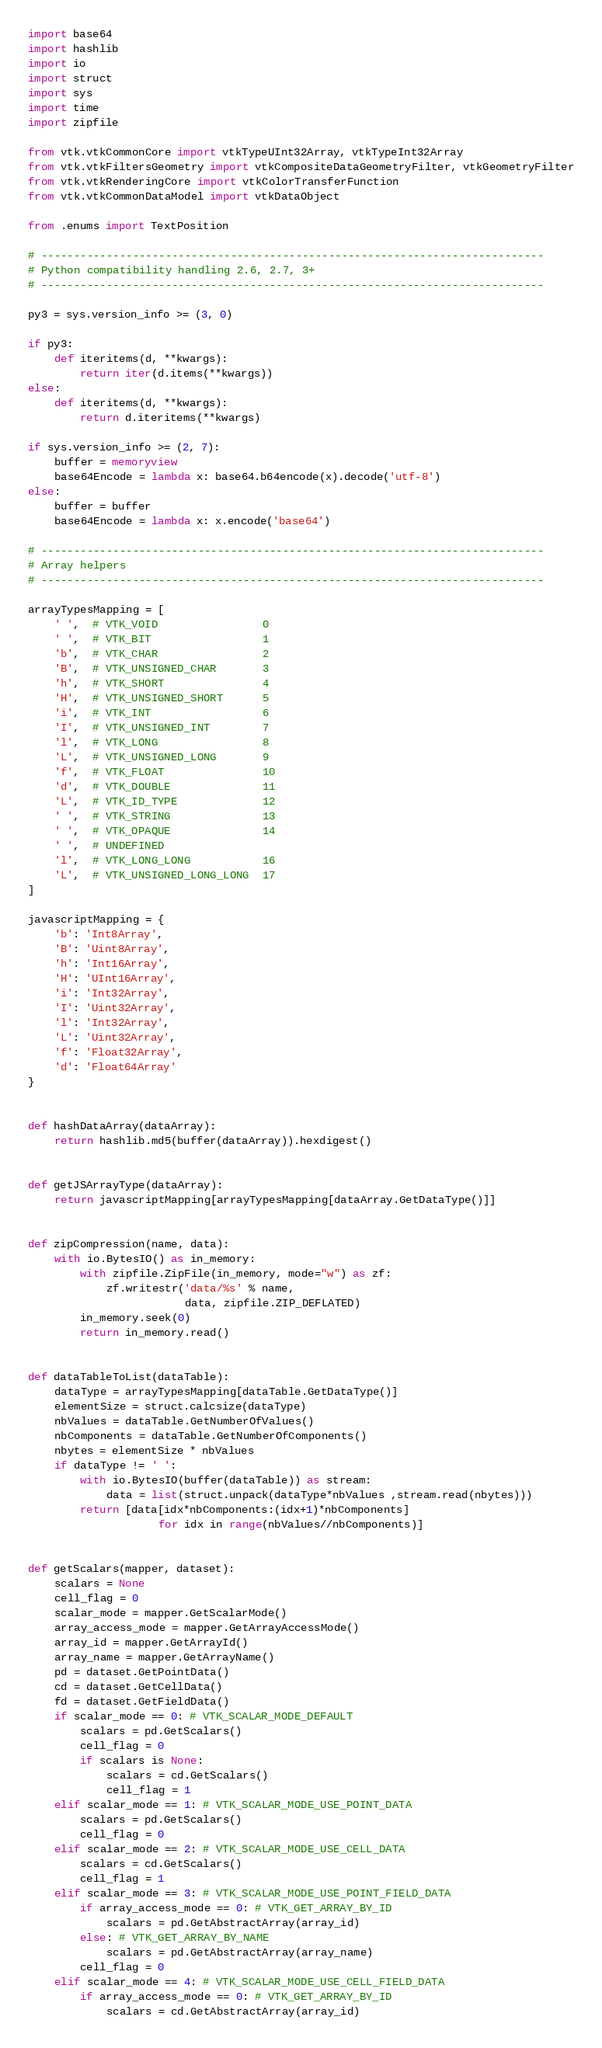Convert code to text. <code><loc_0><loc_0><loc_500><loc_500><_Python_>import base64
import hashlib
import io
import struct
import sys
import time
import zipfile

from vtk.vtkCommonCore import vtkTypeUInt32Array, vtkTypeInt32Array
from vtk.vtkFiltersGeometry import vtkCompositeDataGeometryFilter, vtkGeometryFilter
from vtk.vtkRenderingCore import vtkColorTransferFunction
from vtk.vtkCommonDataModel import vtkDataObject

from .enums import TextPosition

# -----------------------------------------------------------------------------
# Python compatibility handling 2.6, 2.7, 3+
# -----------------------------------------------------------------------------

py3 = sys.version_info >= (3, 0)

if py3:
    def iteritems(d, **kwargs):
        return iter(d.items(**kwargs))
else:
    def iteritems(d, **kwargs):
        return d.iteritems(**kwargs)

if sys.version_info >= (2, 7):
    buffer = memoryview
    base64Encode = lambda x: base64.b64encode(x).decode('utf-8')
else:
    buffer = buffer
    base64Encode = lambda x: x.encode('base64')

# -----------------------------------------------------------------------------
# Array helpers
# -----------------------------------------------------------------------------

arrayTypesMapping = [
    ' ',  # VTK_VOID                0
    ' ',  # VTK_BIT                 1
    'b',  # VTK_CHAR                2
    'B',  # VTK_UNSIGNED_CHAR       3
    'h',  # VTK_SHORT               4
    'H',  # VTK_UNSIGNED_SHORT      5
    'i',  # VTK_INT                 6
    'I',  # VTK_UNSIGNED_INT        7
    'l',  # VTK_LONG                8
    'L',  # VTK_UNSIGNED_LONG       9
    'f',  # VTK_FLOAT               10
    'd',  # VTK_DOUBLE              11
    'L',  # VTK_ID_TYPE             12
    ' ',  # VTK_STRING              13
    ' ',  # VTK_OPAQUE              14
    ' ',  # UNDEFINED
    'l',  # VTK_LONG_LONG           16
    'L',  # VTK_UNSIGNED_LONG_LONG  17
]

javascriptMapping = {
    'b': 'Int8Array',
    'B': 'Uint8Array',
    'h': 'Int16Array',
    'H': 'UInt16Array',
    'i': 'Int32Array',
    'I': 'Uint32Array',
    'l': 'Int32Array',
    'L': 'Uint32Array',
    'f': 'Float32Array',
    'd': 'Float64Array'
}


def hashDataArray(dataArray):
    return hashlib.md5(buffer(dataArray)).hexdigest()


def getJSArrayType(dataArray):
    return javascriptMapping[arrayTypesMapping[dataArray.GetDataType()]]


def zipCompression(name, data):
    with io.BytesIO() as in_memory:
        with zipfile.ZipFile(in_memory, mode="w") as zf:
            zf.writestr('data/%s' % name,
                        data, zipfile.ZIP_DEFLATED)
        in_memory.seek(0)
        return in_memory.read()


def dataTableToList(dataTable):
    dataType = arrayTypesMapping[dataTable.GetDataType()]
    elementSize = struct.calcsize(dataType)
    nbValues = dataTable.GetNumberOfValues()
    nbComponents = dataTable.GetNumberOfComponents()
    nbytes = elementSize * nbValues
    if dataType != ' ':
        with io.BytesIO(buffer(dataTable)) as stream:
            data = list(struct.unpack(dataType*nbValues ,stream.read(nbytes)))
        return [data[idx*nbComponents:(idx+1)*nbComponents]
                    for idx in range(nbValues//nbComponents)]


def getScalars(mapper, dataset):
    scalars = None
    cell_flag = 0
    scalar_mode = mapper.GetScalarMode()
    array_access_mode = mapper.GetArrayAccessMode()
    array_id = mapper.GetArrayId()
    array_name = mapper.GetArrayName()
    pd = dataset.GetPointData()
    cd = dataset.GetCellData()
    fd = dataset.GetFieldData()
    if scalar_mode == 0: # VTK_SCALAR_MODE_DEFAULT
        scalars = pd.GetScalars()
        cell_flag = 0
        if scalars is None:
            scalars = cd.GetScalars()
            cell_flag = 1
    elif scalar_mode == 1: # VTK_SCALAR_MODE_USE_POINT_DATA
        scalars = pd.GetScalars()
        cell_flag = 0
    elif scalar_mode == 2: # VTK_SCALAR_MODE_USE_CELL_DATA
        scalars = cd.GetScalars()
        cell_flag = 1
    elif scalar_mode == 3: # VTK_SCALAR_MODE_USE_POINT_FIELD_DATA
        if array_access_mode == 0: # VTK_GET_ARRAY_BY_ID
            scalars = pd.GetAbstractArray(array_id)
        else: # VTK_GET_ARRAY_BY_NAME
            scalars = pd.GetAbstractArray(array_name)
        cell_flag = 0
    elif scalar_mode == 4: # VTK_SCALAR_MODE_USE_CELL_FIELD_DATA
        if array_access_mode == 0: # VTK_GET_ARRAY_BY_ID
            scalars = cd.GetAbstractArray(array_id)</code> 